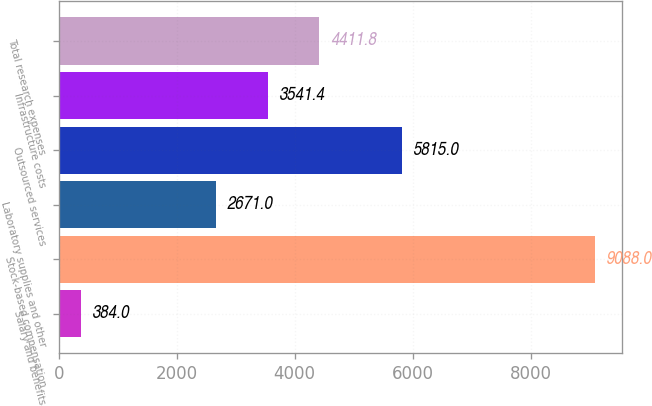Convert chart to OTSL. <chart><loc_0><loc_0><loc_500><loc_500><bar_chart><fcel>Salary and benefits<fcel>Stock-based compensation<fcel>Laboratory supplies and other<fcel>Outsourced services<fcel>Infrastructure costs<fcel>Total research expenses<nl><fcel>384<fcel>9088<fcel>2671<fcel>5815<fcel>3541.4<fcel>4411.8<nl></chart> 